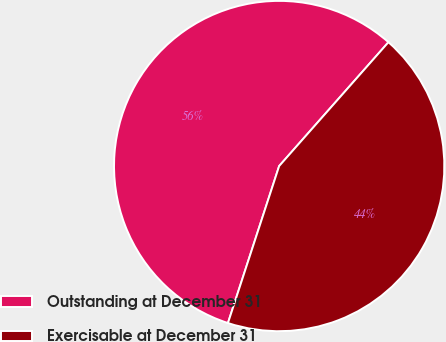<chart> <loc_0><loc_0><loc_500><loc_500><pie_chart><fcel>Outstanding at December 31<fcel>Exercisable at December 31<nl><fcel>56.49%<fcel>43.51%<nl></chart> 